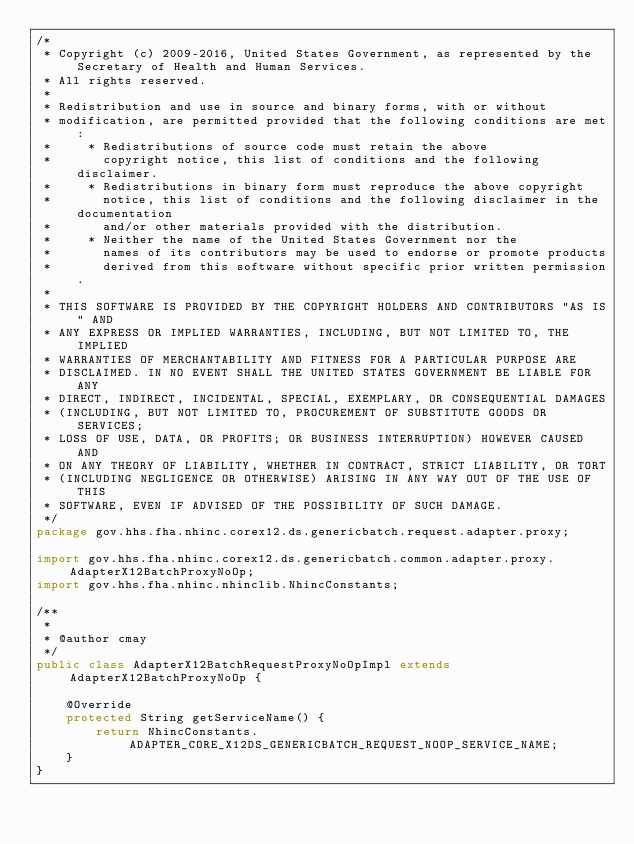Convert code to text. <code><loc_0><loc_0><loc_500><loc_500><_Java_>/*
 * Copyright (c) 2009-2016, United States Government, as represented by the Secretary of Health and Human Services.
 * All rights reserved.
 *
 * Redistribution and use in source and binary forms, with or without
 * modification, are permitted provided that the following conditions are met:
 *     * Redistributions of source code must retain the above
 *       copyright notice, this list of conditions and the following disclaimer.
 *     * Redistributions in binary form must reproduce the above copyright
 *       notice, this list of conditions and the following disclaimer in the documentation
 *       and/or other materials provided with the distribution.
 *     * Neither the name of the United States Government nor the
 *       names of its contributors may be used to endorse or promote products
 *       derived from this software without specific prior written permission.
 *
 * THIS SOFTWARE IS PROVIDED BY THE COPYRIGHT HOLDERS AND CONTRIBUTORS "AS IS" AND
 * ANY EXPRESS OR IMPLIED WARRANTIES, INCLUDING, BUT NOT LIMITED TO, THE IMPLIED
 * WARRANTIES OF MERCHANTABILITY AND FITNESS FOR A PARTICULAR PURPOSE ARE
 * DISCLAIMED. IN NO EVENT SHALL THE UNITED STATES GOVERNMENT BE LIABLE FOR ANY
 * DIRECT, INDIRECT, INCIDENTAL, SPECIAL, EXEMPLARY, OR CONSEQUENTIAL DAMAGES
 * (INCLUDING, BUT NOT LIMITED TO, PROCUREMENT OF SUBSTITUTE GOODS OR SERVICES;
 * LOSS OF USE, DATA, OR PROFITS; OR BUSINESS INTERRUPTION) HOWEVER CAUSED AND
 * ON ANY THEORY OF LIABILITY, WHETHER IN CONTRACT, STRICT LIABILITY, OR TORT
 * (INCLUDING NEGLIGENCE OR OTHERWISE) ARISING IN ANY WAY OUT OF THE USE OF THIS
 * SOFTWARE, EVEN IF ADVISED OF THE POSSIBILITY OF SUCH DAMAGE.
 */
package gov.hhs.fha.nhinc.corex12.ds.genericbatch.request.adapter.proxy;

import gov.hhs.fha.nhinc.corex12.ds.genericbatch.common.adapter.proxy.AdapterX12BatchProxyNoOp;
import gov.hhs.fha.nhinc.nhinclib.NhincConstants;

/**
 *
 * @author cmay
 */
public class AdapterX12BatchRequestProxyNoOpImpl extends AdapterX12BatchProxyNoOp {

    @Override
    protected String getServiceName() {
        return NhincConstants.ADAPTER_CORE_X12DS_GENERICBATCH_REQUEST_NOOP_SERVICE_NAME;
    }
}
</code> 